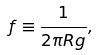<formula> <loc_0><loc_0><loc_500><loc_500>f \equiv \frac { 1 } { 2 \pi R g } ,</formula> 